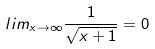Convert formula to latex. <formula><loc_0><loc_0><loc_500><loc_500>l i m _ { x \rightarrow \infty } \frac { 1 } { \sqrt { x + 1 } } = 0</formula> 